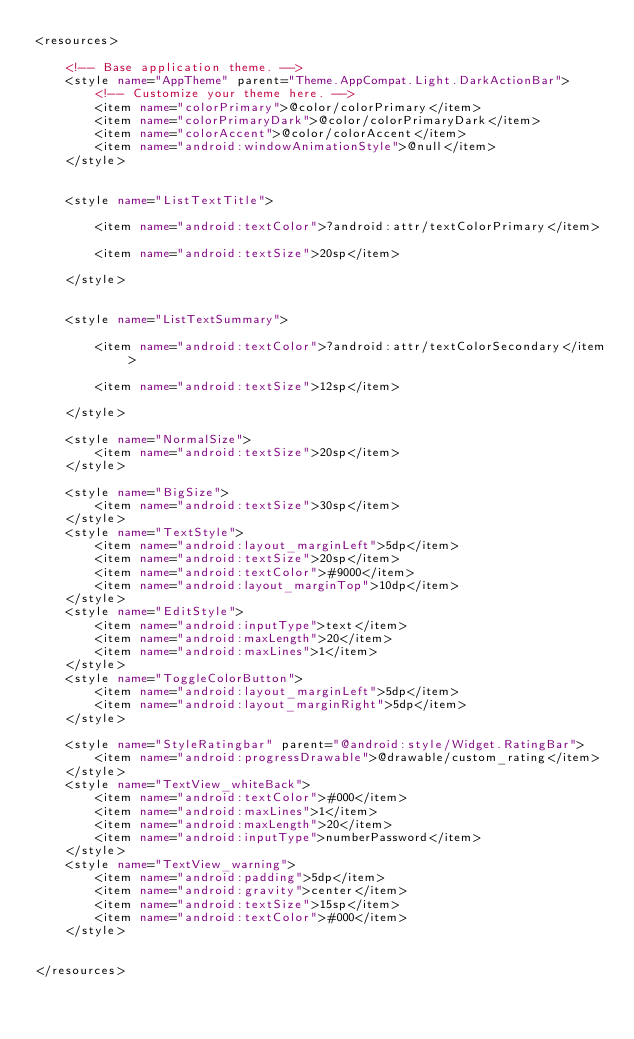<code> <loc_0><loc_0><loc_500><loc_500><_XML_><resources>

    <!-- Base application theme. -->
    <style name="AppTheme" parent="Theme.AppCompat.Light.DarkActionBar">
        <!-- Customize your theme here. -->
        <item name="colorPrimary">@color/colorPrimary</item>
        <item name="colorPrimaryDark">@color/colorPrimaryDark</item>
        <item name="colorAccent">@color/colorAccent</item>
        <item name="android:windowAnimationStyle">@null</item>
    </style>


    <style name="ListTextTitle">

        <item name="android:textColor">?android:attr/textColorPrimary</item>

        <item name="android:textSize">20sp</item>

    </style>


    <style name="ListTextSummary">

        <item name="android:textColor">?android:attr/textColorSecondary</item>

        <item name="android:textSize">12sp</item>

    </style>

    <style name="NormalSize">
        <item name="android:textSize">20sp</item>
    </style>

    <style name="BigSize">
        <item name="android:textSize">30sp</item>
    </style>
    <style name="TextStyle">
        <item name="android:layout_marginLeft">5dp</item>
        <item name="android:textSize">20sp</item>
        <item name="android:textColor">#9000</item>
        <item name="android:layout_marginTop">10dp</item>
    </style>
    <style name="EditStyle">
        <item name="android:inputType">text</item>
        <item name="android:maxLength">20</item>
        <item name="android:maxLines">1</item>
    </style>
    <style name="ToggleColorButton">
        <item name="android:layout_marginLeft">5dp</item>
        <item name="android:layout_marginRight">5dp</item>
    </style>

    <style name="StyleRatingbar" parent="@android:style/Widget.RatingBar">
        <item name="android:progressDrawable">@drawable/custom_rating</item>
    </style>
    <style name="TextView_whiteBack">
        <item name="android:textColor">#000</item>
        <item name="android:maxLines">1</item>
        <item name="android:maxLength">20</item>
        <item name="android:inputType">numberPassword</item>
    </style>
    <style name="TextView_warning">
        <item name="android:padding">5dp</item>
        <item name="android:gravity">center</item>
        <item name="android:textSize">15sp</item>
        <item name="android:textColor">#000</item>
    </style>


</resources>
</code> 